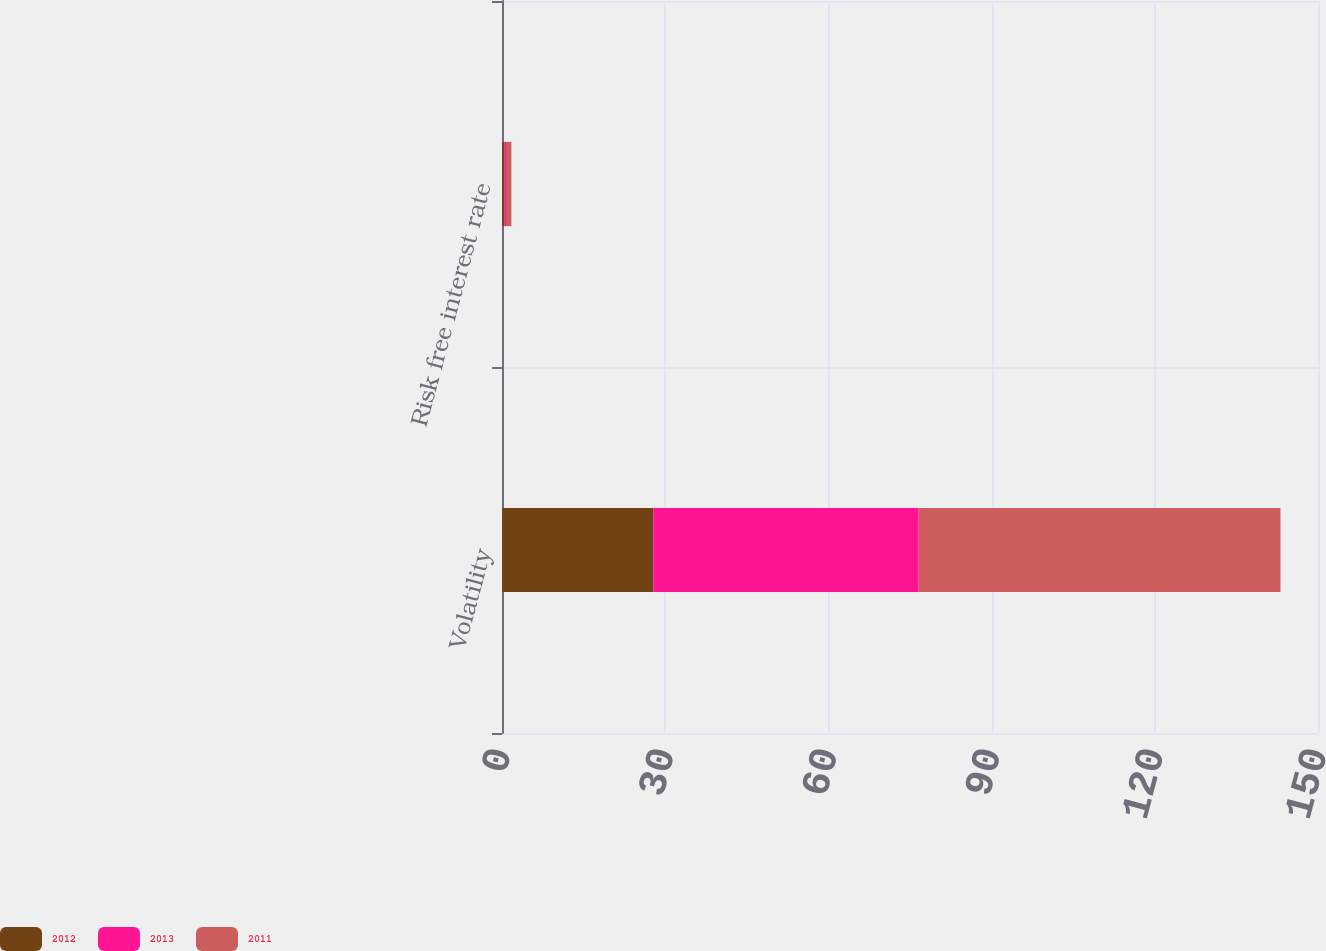Convert chart. <chart><loc_0><loc_0><loc_500><loc_500><stacked_bar_chart><ecel><fcel>Volatility<fcel>Risk free interest rate<nl><fcel>2012<fcel>27.8<fcel>0.42<nl><fcel>2013<fcel>48.8<fcel>0.32<nl><fcel>2011<fcel>66.5<fcel>0.98<nl></chart> 